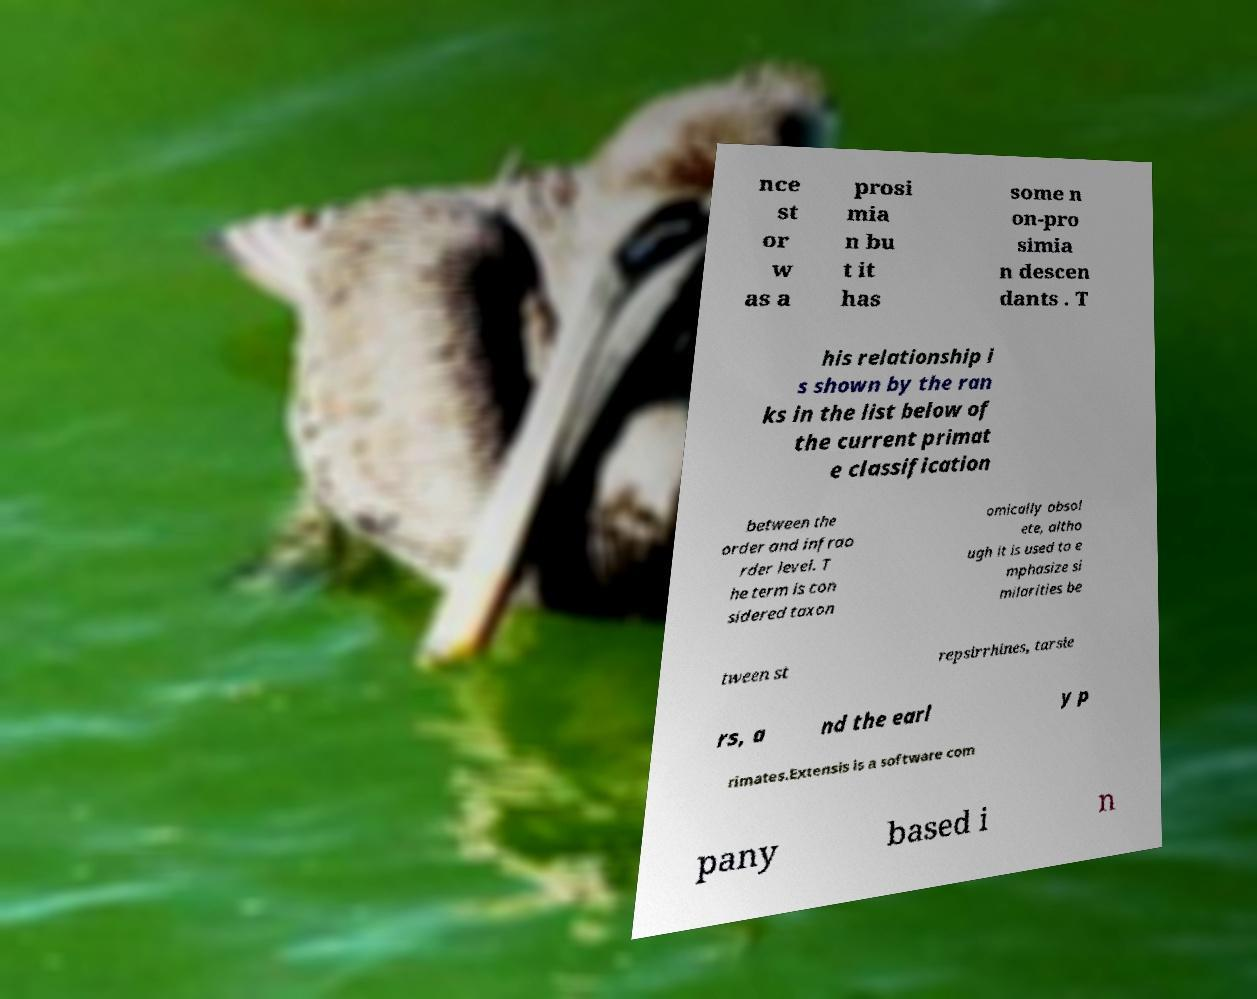For documentation purposes, I need the text within this image transcribed. Could you provide that? nce st or w as a prosi mia n bu t it has some n on-pro simia n descen dants . T his relationship i s shown by the ran ks in the list below of the current primat e classification between the order and infrao rder level. T he term is con sidered taxon omically obsol ete, altho ugh it is used to e mphasize si milarities be tween st repsirrhines, tarsie rs, a nd the earl y p rimates.Extensis is a software com pany based i n 